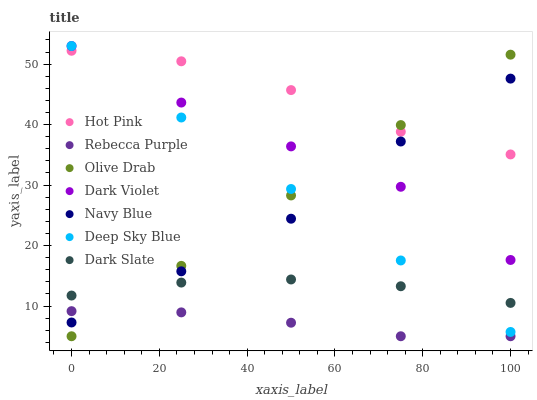Does Rebecca Purple have the minimum area under the curve?
Answer yes or no. Yes. Does Hot Pink have the maximum area under the curve?
Answer yes or no. Yes. Does Dark Violet have the minimum area under the curve?
Answer yes or no. No. Does Dark Violet have the maximum area under the curve?
Answer yes or no. No. Is Olive Drab the smoothest?
Answer yes or no. Yes. Is Hot Pink the roughest?
Answer yes or no. Yes. Is Dark Violet the smoothest?
Answer yes or no. No. Is Dark Violet the roughest?
Answer yes or no. No. Does Rebecca Purple have the lowest value?
Answer yes or no. Yes. Does Dark Violet have the lowest value?
Answer yes or no. No. Does Deep Sky Blue have the highest value?
Answer yes or no. Yes. Does Hot Pink have the highest value?
Answer yes or no. No. Is Rebecca Purple less than Dark Violet?
Answer yes or no. Yes. Is Dark Slate greater than Rebecca Purple?
Answer yes or no. Yes. Does Navy Blue intersect Rebecca Purple?
Answer yes or no. Yes. Is Navy Blue less than Rebecca Purple?
Answer yes or no. No. Is Navy Blue greater than Rebecca Purple?
Answer yes or no. No. Does Rebecca Purple intersect Dark Violet?
Answer yes or no. No. 